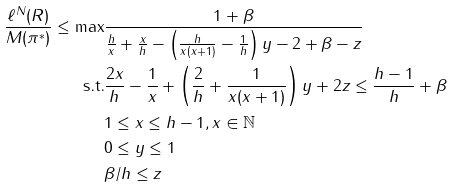Convert formula to latex. <formula><loc_0><loc_0><loc_500><loc_500>\frac { \ell ^ { N } ( R ) } { M ( \pi ^ { * } ) } \leq \max & \frac { 1 + \beta } { \frac { h } { x } + \frac { x } { h } - \left ( \frac { h } { x ( x + 1 ) } - \frac { 1 } { h } \right ) y - 2 + \beta - z } \\ \text {s.t.} & \frac { 2 x } h - \frac { 1 } { x } + \left ( \frac { 2 } { h } + \frac { 1 } { x ( x + 1 ) } \right ) y + 2 z \leq \frac { h - 1 } { h } + \beta \\ & 1 \leq x \leq h - 1 , x \in \mathbb { N } \\ & 0 \leq y \leq 1 \\ & \beta / { h } \leq z</formula> 